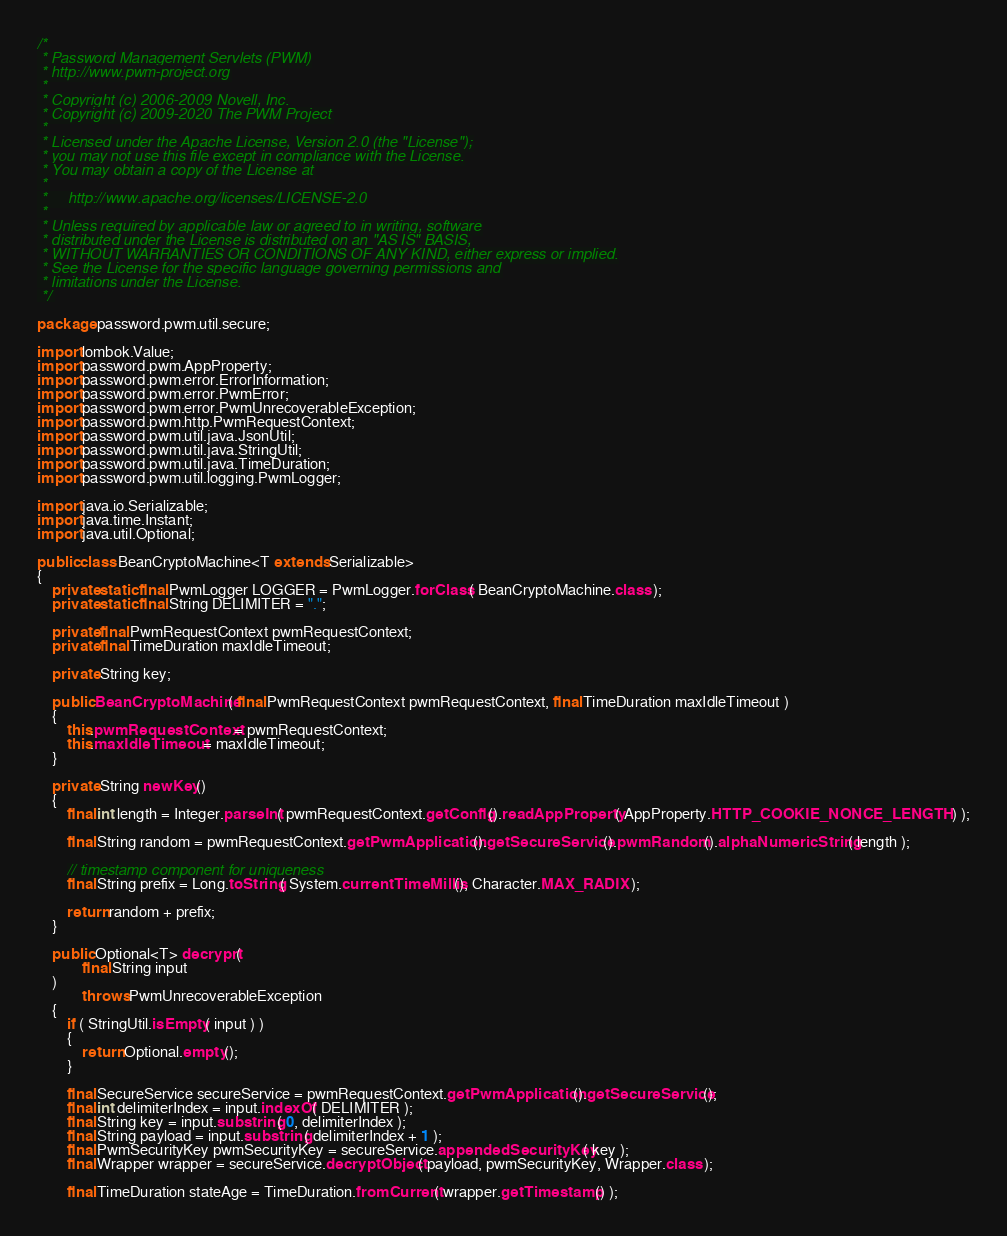Convert code to text. <code><loc_0><loc_0><loc_500><loc_500><_Java_>/*
 * Password Management Servlets (PWM)
 * http://www.pwm-project.org
 *
 * Copyright (c) 2006-2009 Novell, Inc.
 * Copyright (c) 2009-2020 The PWM Project
 *
 * Licensed under the Apache License, Version 2.0 (the "License");
 * you may not use this file except in compliance with the License.
 * You may obtain a copy of the License at
 *
 *     http://www.apache.org/licenses/LICENSE-2.0
 *
 * Unless required by applicable law or agreed to in writing, software
 * distributed under the License is distributed on an "AS IS" BASIS,
 * WITHOUT WARRANTIES OR CONDITIONS OF ANY KIND, either express or implied.
 * See the License for the specific language governing permissions and
 * limitations under the License.
 */

package password.pwm.util.secure;

import lombok.Value;
import password.pwm.AppProperty;
import password.pwm.error.ErrorInformation;
import password.pwm.error.PwmError;
import password.pwm.error.PwmUnrecoverableException;
import password.pwm.http.PwmRequestContext;
import password.pwm.util.java.JsonUtil;
import password.pwm.util.java.StringUtil;
import password.pwm.util.java.TimeDuration;
import password.pwm.util.logging.PwmLogger;

import java.io.Serializable;
import java.time.Instant;
import java.util.Optional;

public class BeanCryptoMachine<T extends Serializable>
{
    private static final PwmLogger LOGGER = PwmLogger.forClass( BeanCryptoMachine.class );
    private static final String DELIMITER = ".";

    private final PwmRequestContext pwmRequestContext;
    private final TimeDuration maxIdleTimeout;

    private String key;

    public BeanCryptoMachine( final PwmRequestContext pwmRequestContext, final TimeDuration maxIdleTimeout )
    {
        this.pwmRequestContext = pwmRequestContext;
        this.maxIdleTimeout = maxIdleTimeout;
    }

    private String newKey()
    {
        final int length = Integer.parseInt( pwmRequestContext.getConfig().readAppProperty( AppProperty.HTTP_COOKIE_NONCE_LENGTH ) );

        final String random = pwmRequestContext.getPwmApplication().getSecureService().pwmRandom().alphaNumericString( length );

        // timestamp component for uniqueness
        final String prefix = Long.toString( System.currentTimeMillis(), Character.MAX_RADIX );

        return random + prefix;
    }

    public Optional<T> decryprt(
            final String input
    )
            throws PwmUnrecoverableException
    {
        if ( StringUtil.isEmpty( input ) )
        {
            return Optional.empty();
        }

        final SecureService secureService = pwmRequestContext.getPwmApplication().getSecureService();
        final int delimiterIndex = input.indexOf( DELIMITER );
        final String key = input.substring( 0, delimiterIndex );
        final String payload = input.substring( delimiterIndex + 1 );
        final PwmSecurityKey pwmSecurityKey = secureService.appendedSecurityKey( key );
        final Wrapper wrapper = secureService.decryptObject( payload, pwmSecurityKey, Wrapper.class );

        final TimeDuration stateAge = TimeDuration.fromCurrent( wrapper.getTimestamp() );</code> 